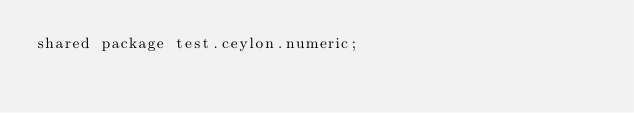Convert code to text. <code><loc_0><loc_0><loc_500><loc_500><_Ceylon_>shared package test.ceylon.numeric;
</code> 